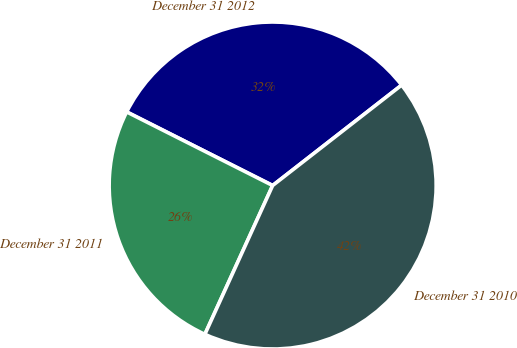Convert chart to OTSL. <chart><loc_0><loc_0><loc_500><loc_500><pie_chart><fcel>December 31 2012<fcel>December 31 2011<fcel>December 31 2010<nl><fcel>32.04%<fcel>25.63%<fcel>42.33%<nl></chart> 